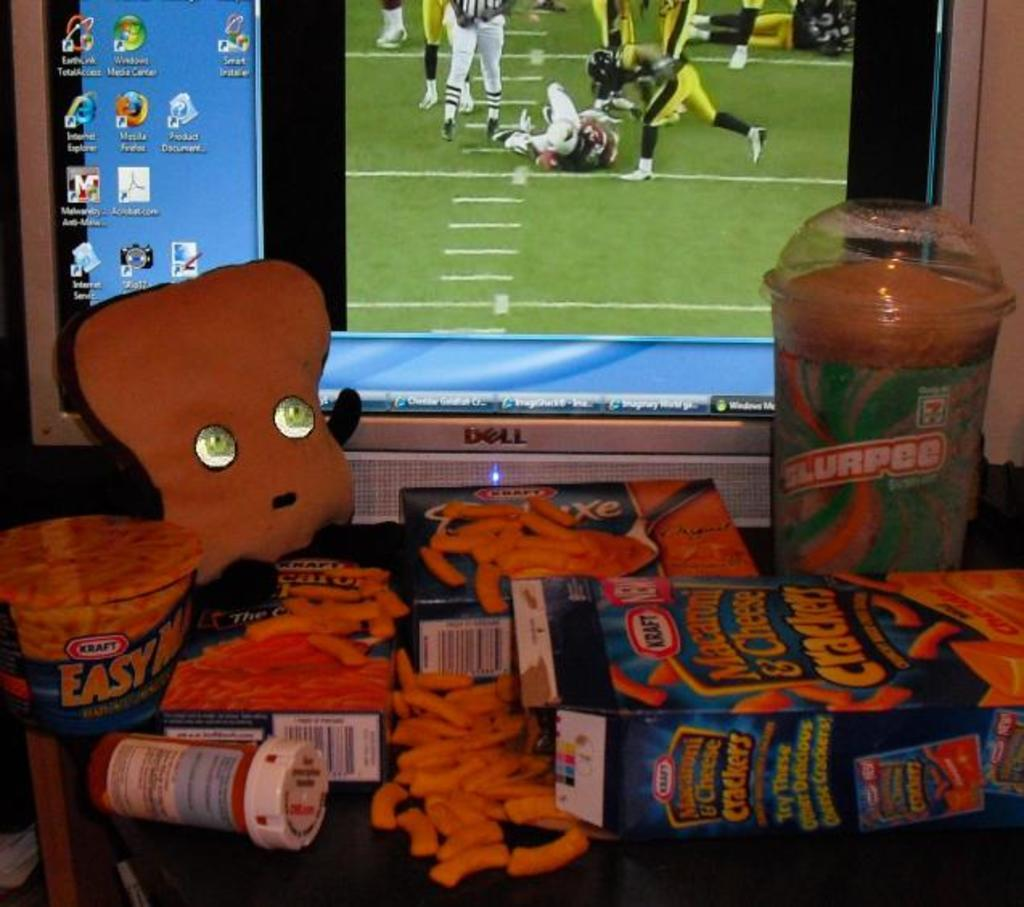<image>
Describe the image concisely. Dell computer sceen that has a football game being watched with Mac and cheese boxes in front of it. 